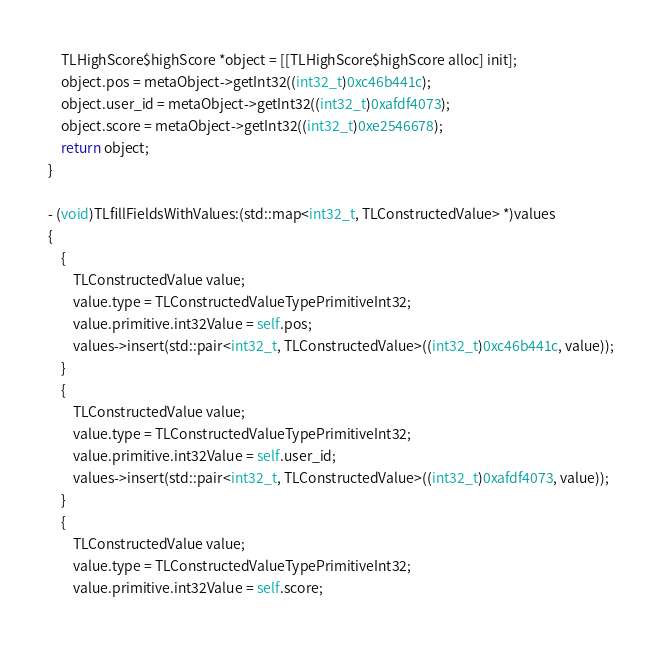<code> <loc_0><loc_0><loc_500><loc_500><_ObjectiveC_>    TLHighScore$highScore *object = [[TLHighScore$highScore alloc] init];
    object.pos = metaObject->getInt32((int32_t)0xc46b441c);
    object.user_id = metaObject->getInt32((int32_t)0xafdf4073);
    object.score = metaObject->getInt32((int32_t)0xe2546678);
    return object;
}

- (void)TLfillFieldsWithValues:(std::map<int32_t, TLConstructedValue> *)values
{
    {
        TLConstructedValue value;
        value.type = TLConstructedValueTypePrimitiveInt32;
        value.primitive.int32Value = self.pos;
        values->insert(std::pair<int32_t, TLConstructedValue>((int32_t)0xc46b441c, value));
    }
    {
        TLConstructedValue value;
        value.type = TLConstructedValueTypePrimitiveInt32;
        value.primitive.int32Value = self.user_id;
        values->insert(std::pair<int32_t, TLConstructedValue>((int32_t)0xafdf4073, value));
    }
    {
        TLConstructedValue value;
        value.type = TLConstructedValueTypePrimitiveInt32;
        value.primitive.int32Value = self.score;</code> 